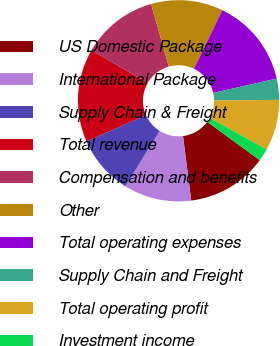Convert chart. <chart><loc_0><loc_0><loc_500><loc_500><pie_chart><fcel>US Domestic Package<fcel>International Package<fcel>Supply Chain & Freight<fcel>Total revenue<fcel>Compensation and benefits<fcel>Other<fcel>Total operating expenses<fcel>Supply Chain and Freight<fcel>Total operating profit<fcel>Investment income<nl><fcel>12.93%<fcel>10.88%<fcel>9.52%<fcel>14.97%<fcel>12.24%<fcel>11.56%<fcel>14.29%<fcel>3.4%<fcel>8.16%<fcel>2.04%<nl></chart> 